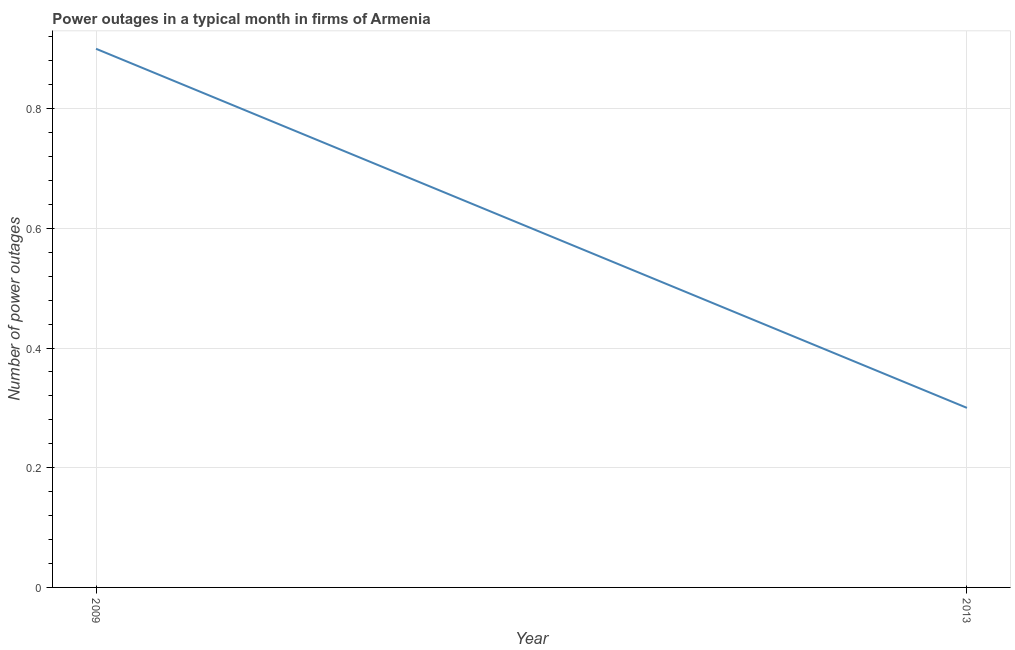Across all years, what is the maximum number of power outages?
Your answer should be very brief. 0.9. In which year was the number of power outages maximum?
Your response must be concise. 2009. In which year was the number of power outages minimum?
Give a very brief answer. 2013. What is the difference between the number of power outages in 2009 and 2013?
Offer a terse response. 0.6. In how many years, is the number of power outages greater than 0.88 ?
Keep it short and to the point. 1. Do a majority of the years between 2013 and 2009 (inclusive) have number of power outages greater than 0.2 ?
Your answer should be compact. No. In how many years, is the number of power outages greater than the average number of power outages taken over all years?
Ensure brevity in your answer.  1. How many lines are there?
Make the answer very short. 1. How many years are there in the graph?
Provide a short and direct response. 2. What is the difference between two consecutive major ticks on the Y-axis?
Give a very brief answer. 0.2. Does the graph contain grids?
Provide a short and direct response. Yes. What is the title of the graph?
Your answer should be very brief. Power outages in a typical month in firms of Armenia. What is the label or title of the X-axis?
Make the answer very short. Year. What is the label or title of the Y-axis?
Offer a terse response. Number of power outages. What is the Number of power outages of 2009?
Provide a succinct answer. 0.9. What is the Number of power outages of 2013?
Make the answer very short. 0.3. What is the difference between the Number of power outages in 2009 and 2013?
Offer a terse response. 0.6. 